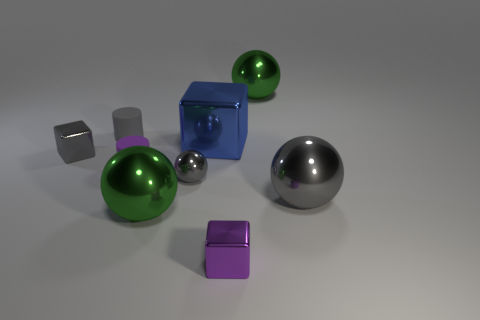Subtract all blue blocks. How many blocks are left? 2 Subtract all red cubes. How many gray balls are left? 2 Subtract all purple cylinders. How many cylinders are left? 1 Subtract all cylinders. How many objects are left? 7 Add 9 gray matte objects. How many gray matte objects are left? 10 Add 6 big green spheres. How many big green spheres exist? 8 Add 1 big blue rubber cylinders. How many objects exist? 10 Subtract 0 brown spheres. How many objects are left? 9 Subtract 1 cylinders. How many cylinders are left? 1 Subtract all purple balls. Subtract all cyan cubes. How many balls are left? 4 